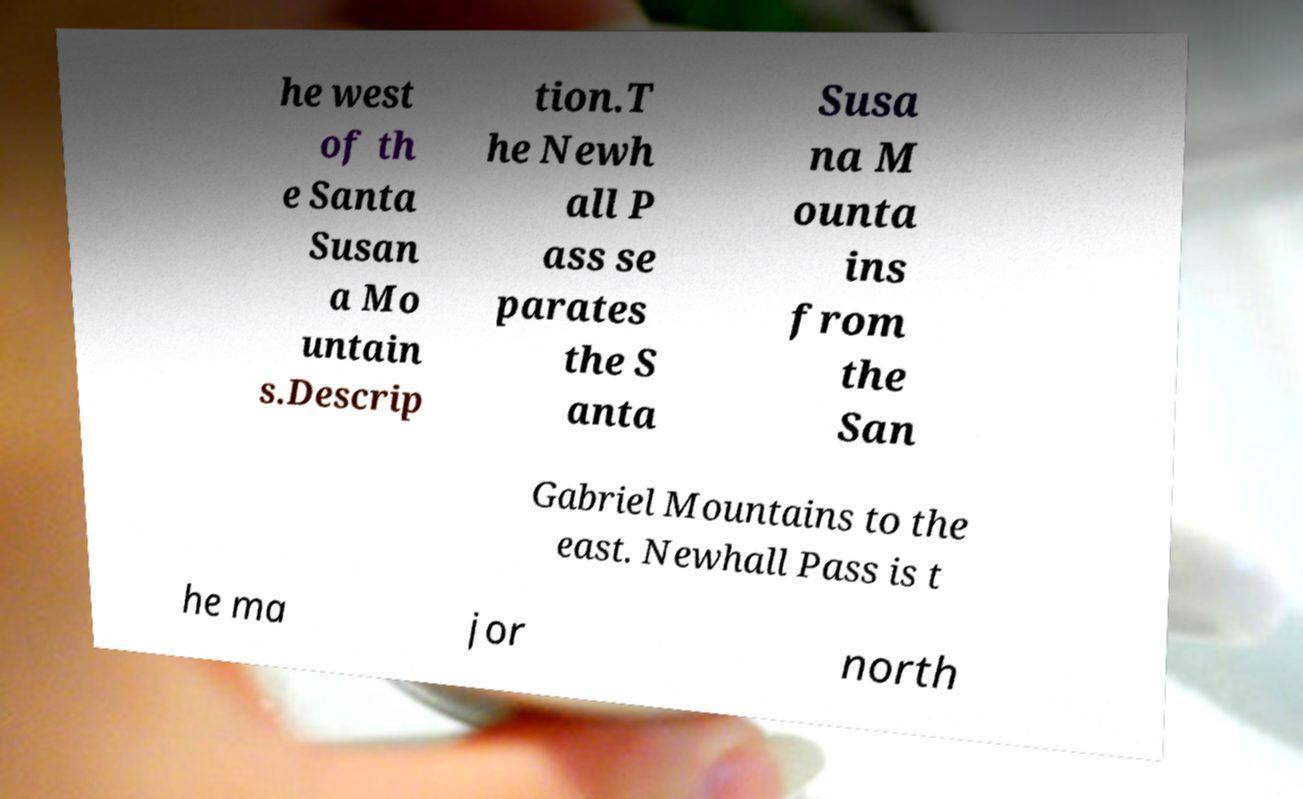Please identify and transcribe the text found in this image. he west of th e Santa Susan a Mo untain s.Descrip tion.T he Newh all P ass se parates the S anta Susa na M ounta ins from the San Gabriel Mountains to the east. Newhall Pass is t he ma jor north 